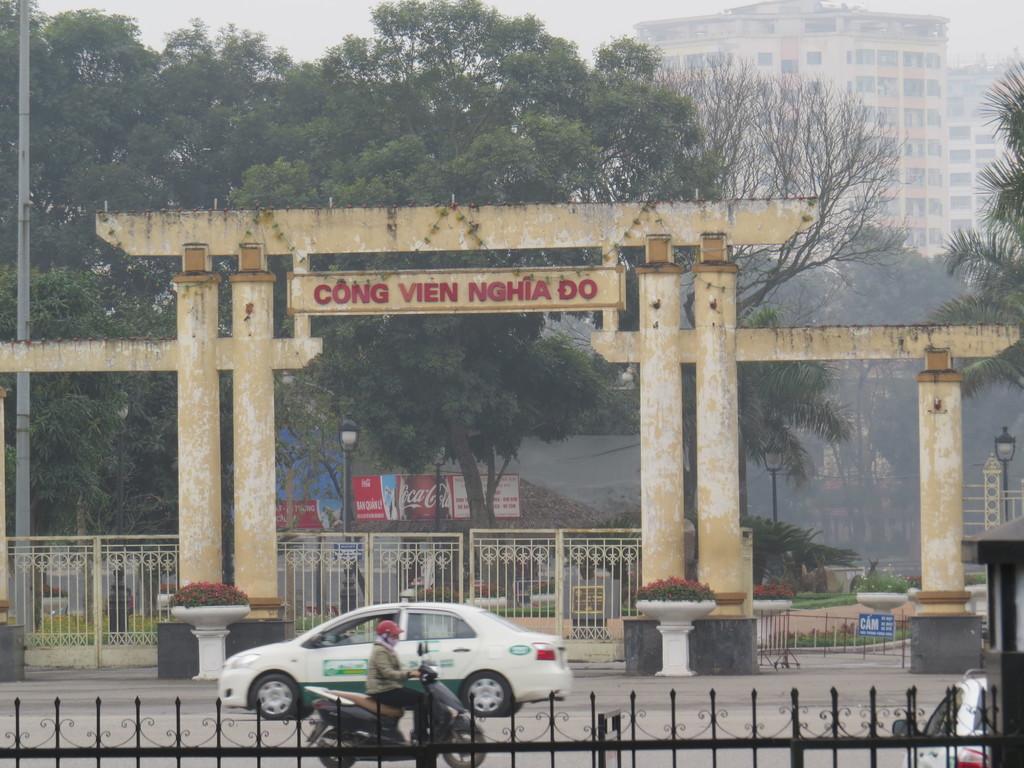Can you describe this image briefly? Here in this picture we can see a car and a scooter present on the road over there and in the front we can see a railing and behind that we can see an arch present and we can see a gate also present over there and we can see trees and plants present all over there and we can see lamp posts present here and there and we can see buildings present all over there. 